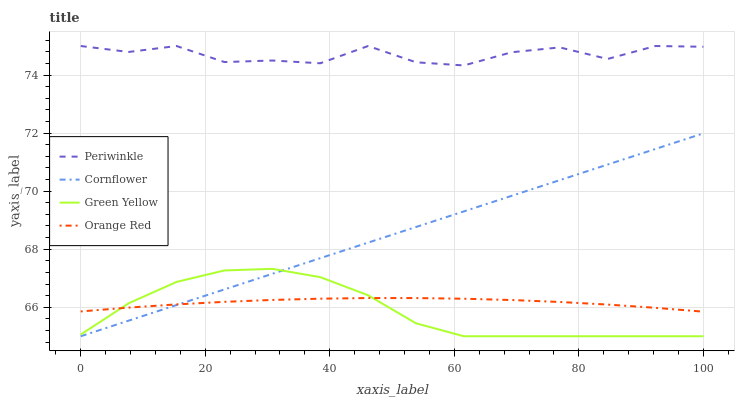Does Green Yellow have the minimum area under the curve?
Answer yes or no. Yes. Does Periwinkle have the maximum area under the curve?
Answer yes or no. Yes. Does Periwinkle have the minimum area under the curve?
Answer yes or no. No. Does Green Yellow have the maximum area under the curve?
Answer yes or no. No. Is Cornflower the smoothest?
Answer yes or no. Yes. Is Periwinkle the roughest?
Answer yes or no. Yes. Is Green Yellow the smoothest?
Answer yes or no. No. Is Green Yellow the roughest?
Answer yes or no. No. Does Periwinkle have the lowest value?
Answer yes or no. No. Does Periwinkle have the highest value?
Answer yes or no. Yes. Does Green Yellow have the highest value?
Answer yes or no. No. Is Cornflower less than Periwinkle?
Answer yes or no. Yes. Is Periwinkle greater than Cornflower?
Answer yes or no. Yes. Does Cornflower intersect Orange Red?
Answer yes or no. Yes. Is Cornflower less than Orange Red?
Answer yes or no. No. Is Cornflower greater than Orange Red?
Answer yes or no. No. Does Cornflower intersect Periwinkle?
Answer yes or no. No. 